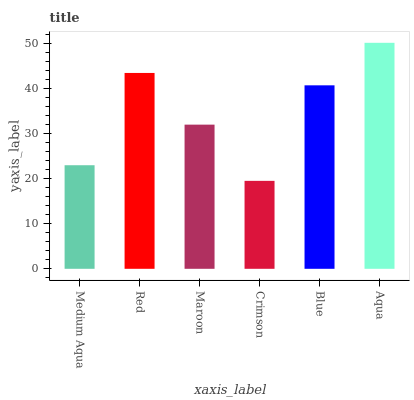Is Crimson the minimum?
Answer yes or no. Yes. Is Aqua the maximum?
Answer yes or no. Yes. Is Red the minimum?
Answer yes or no. No. Is Red the maximum?
Answer yes or no. No. Is Red greater than Medium Aqua?
Answer yes or no. Yes. Is Medium Aqua less than Red?
Answer yes or no. Yes. Is Medium Aqua greater than Red?
Answer yes or no. No. Is Red less than Medium Aqua?
Answer yes or no. No. Is Blue the high median?
Answer yes or no. Yes. Is Maroon the low median?
Answer yes or no. Yes. Is Maroon the high median?
Answer yes or no. No. Is Red the low median?
Answer yes or no. No. 